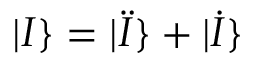<formula> <loc_0><loc_0><loc_500><loc_500>| I \} = | \ddot { I } \} + | \dot { I } \}</formula> 